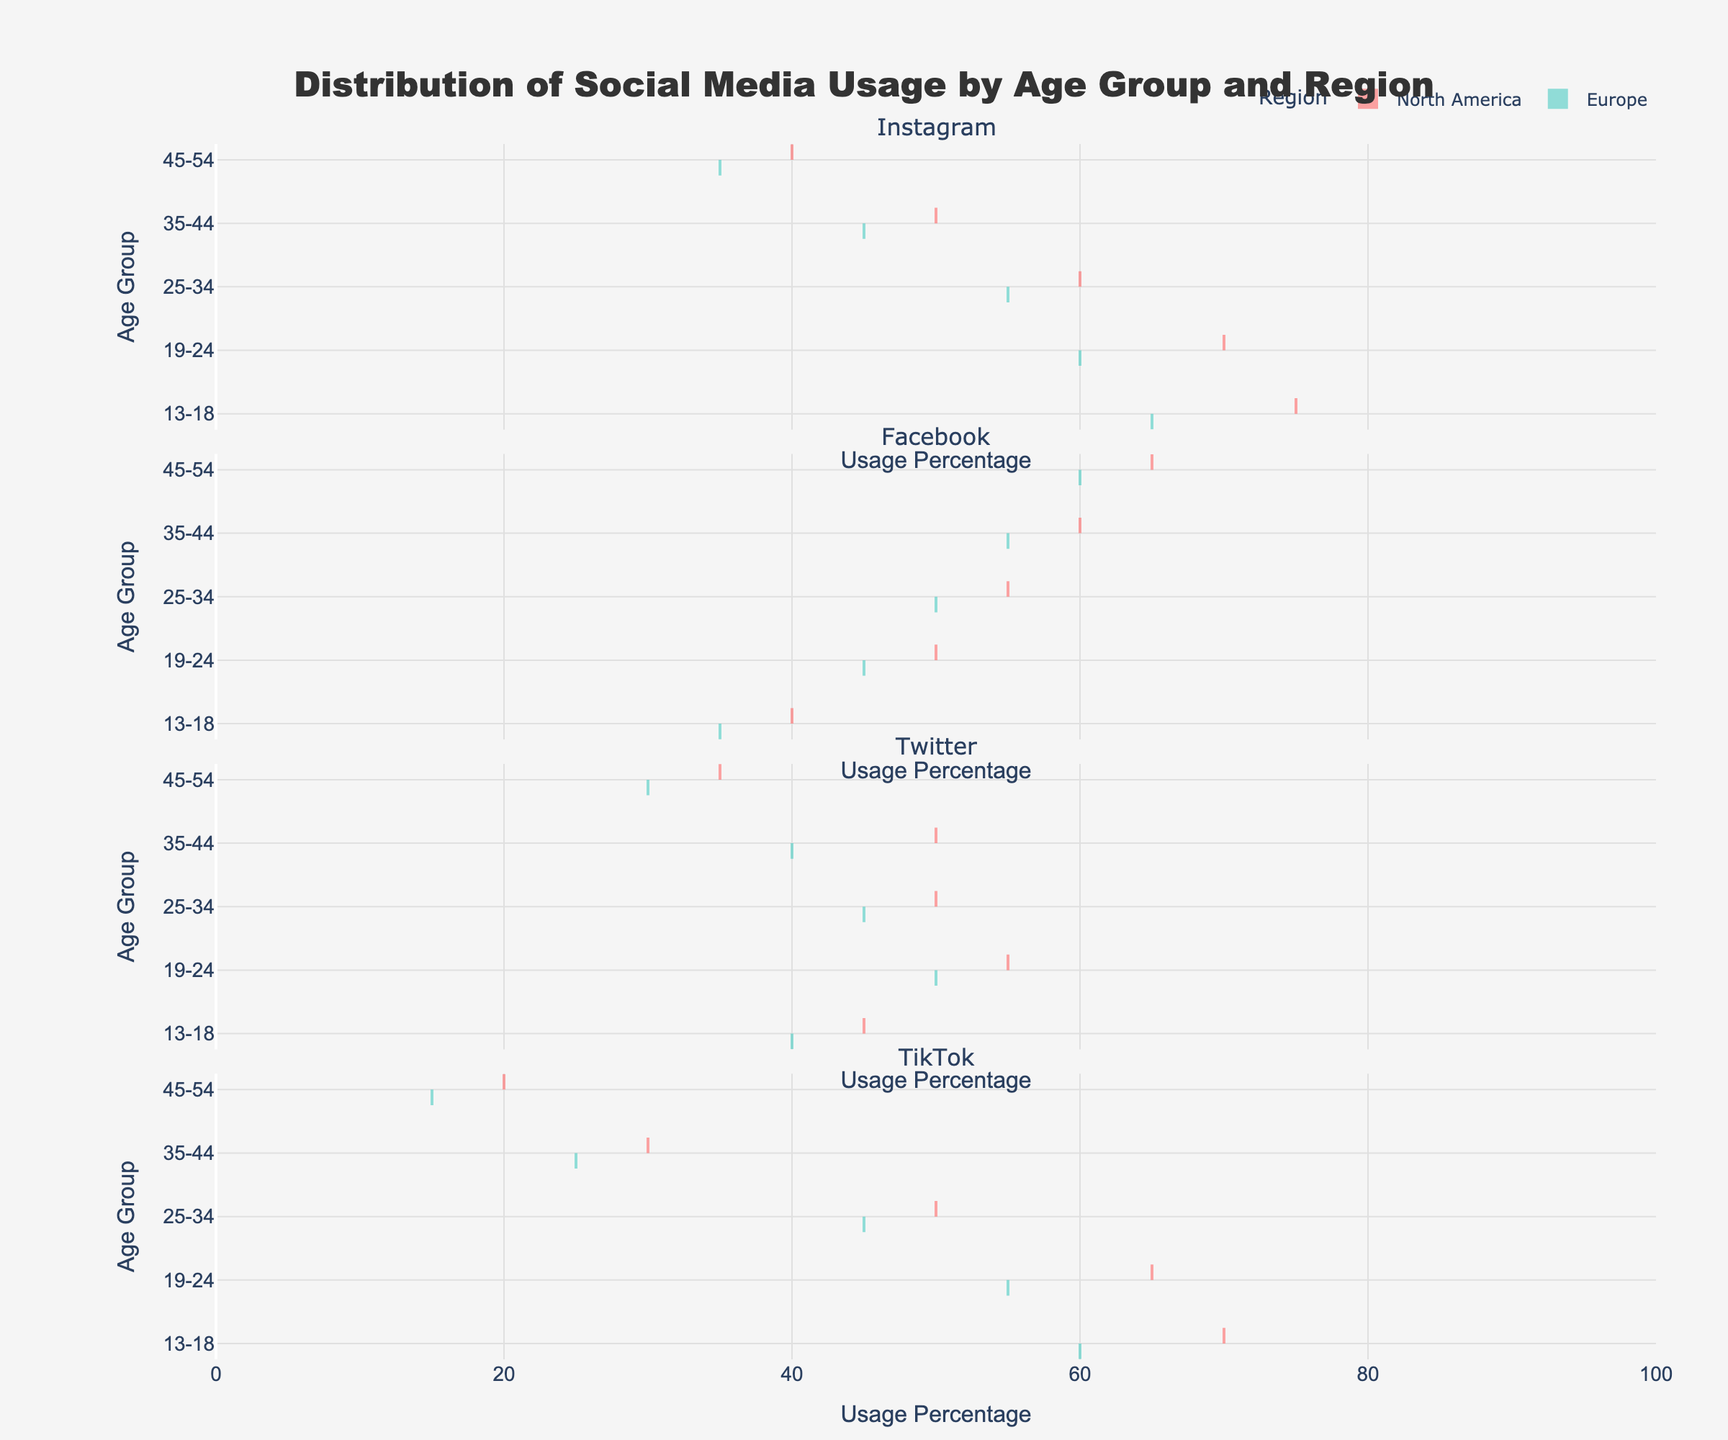what is the title of the figure? The title of the figure is easily found at the top of the plot. It provides a quick overview of what the plot represents.
Answer: Distribution of Social Media Usage by Age Group and Region What is the range of the x-axis? The x-axis represents the usage percentage and spans its values from the minimum to the maximum possible usage percentage. By examining the plot, the range is inclusive and well defined.
Answer: 0 to 100 Which social media platform has the highest usage percentage among the 13-18 age group in North America? Focusing on the plot section for the 13-18 age group in North America and comparing the usage percentages for different platforms, TikTok stands out as having the highest usage percentage.
Answer: TikTok Is there a noticeable difference in TikTok usage between North America and Europe for the 19-24 age group? By comparing the distributions of TikTok usage for the 19-24 age group in both regions on the plot, we can see if there's a significant difference in the spread or central tendency.
Answer: Yes Which social media platform shows a more consistent usage percentage across all age groups in Europe? By looking across the different platforms for Europe, examine how tightly packed the distributions are and how central the usage percentages fall across all age groups.
Answer: Twitter What's the average usage percentage of Instagram for the age group 25-34 in both North America and Europe? To find the average: add the usage percentages of Instagram for the 25-34 age group in North America and Europe, and then divide by 2. The values are 60 and 55. (60 + 55) / 2
Answer: 57.5 Compare the Facebook usage between the 35-44 age group in North America and Europe. Which region has higher usage? By comparing the distributions of Facebook usage for the 35-44 age group in both North America and Europe, we can determine which region has a higher central tendency or higher peaks.
Answer: North America Which age group has the lowest usage percentage of TikTok in Europe? By examining the distribution for TikTok in Europe and identifying the lowest usage percentages among various age groups, we can pinpoint the age group with the minimal usage.
Answer: 45-54 Is the distribution of Instagram usage for the 13-18 age group wider in Europe or North America? Look at the spread or width of the violin plots for Instagram usage within the 13-18 age group in both Europe and North America to see which one covers a broader range of percentages.
Answer: North America 